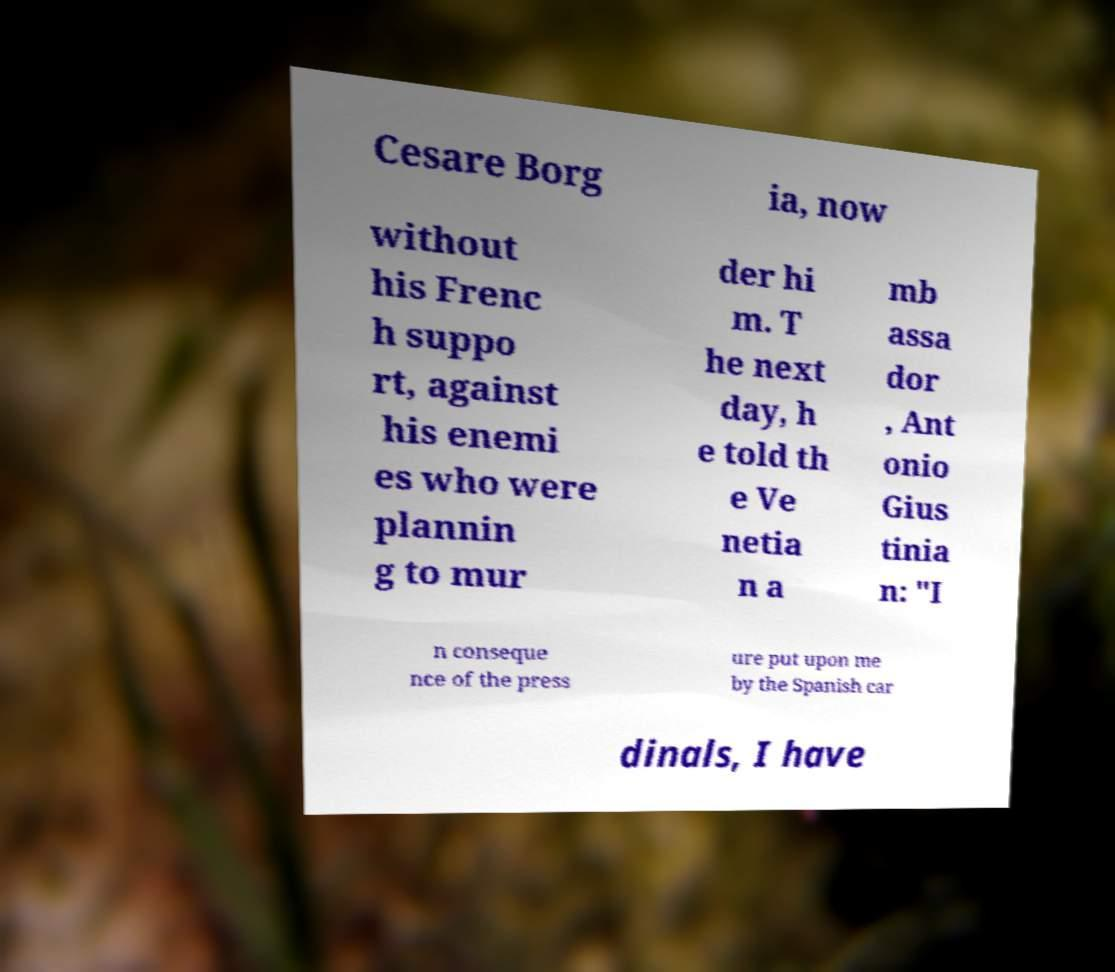There's text embedded in this image that I need extracted. Can you transcribe it verbatim? Cesare Borg ia, now without his Frenc h suppo rt, against his enemi es who were plannin g to mur der hi m. T he next day, h e told th e Ve netia n a mb assa dor , Ant onio Gius tinia n: "I n conseque nce of the press ure put upon me by the Spanish car dinals, I have 